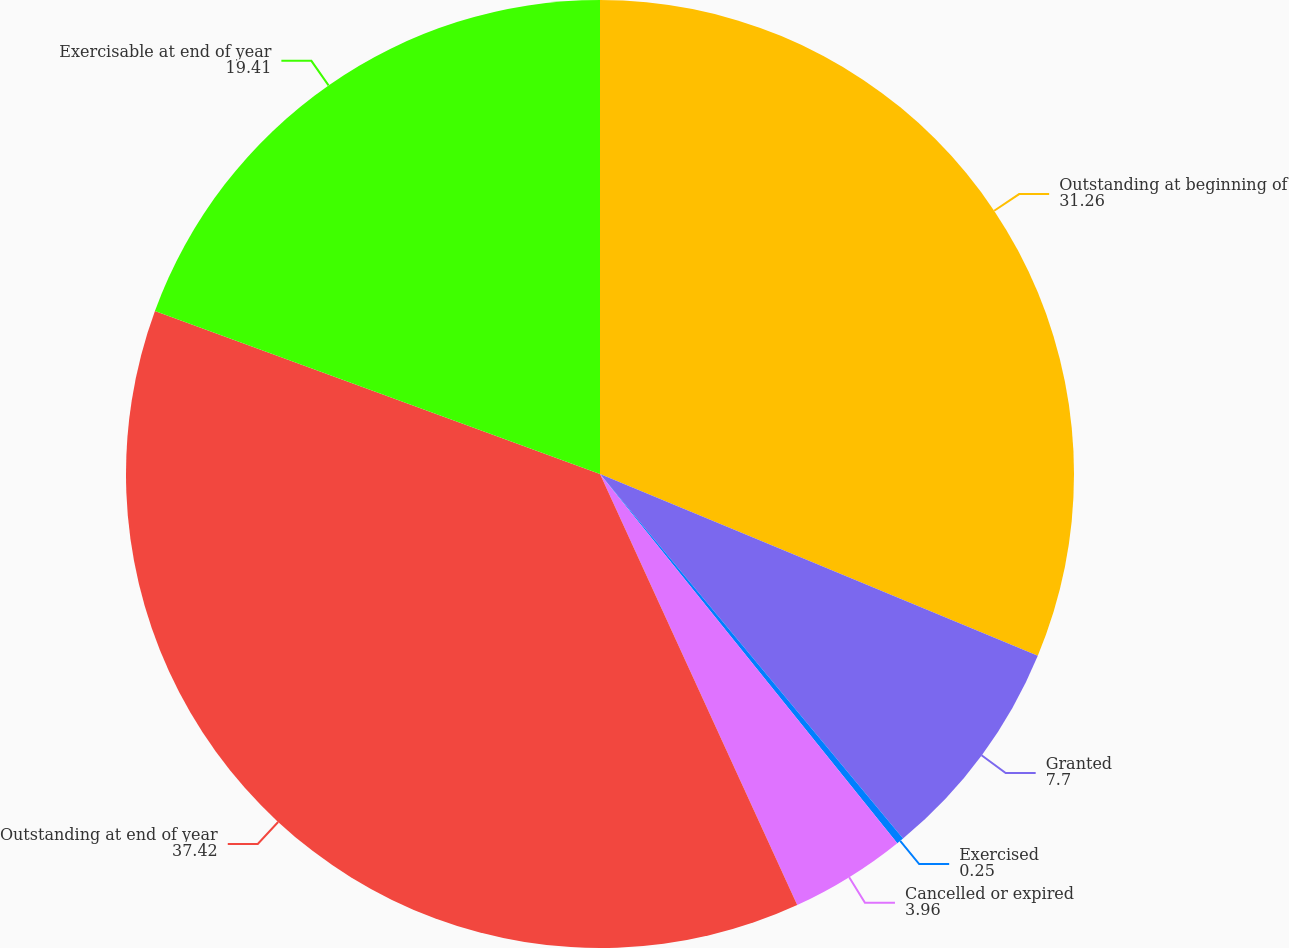Convert chart to OTSL. <chart><loc_0><loc_0><loc_500><loc_500><pie_chart><fcel>Outstanding at beginning of<fcel>Granted<fcel>Exercised<fcel>Cancelled or expired<fcel>Outstanding at end of year<fcel>Exercisable at end of year<nl><fcel>31.26%<fcel>7.7%<fcel>0.25%<fcel>3.96%<fcel>37.42%<fcel>19.41%<nl></chart> 